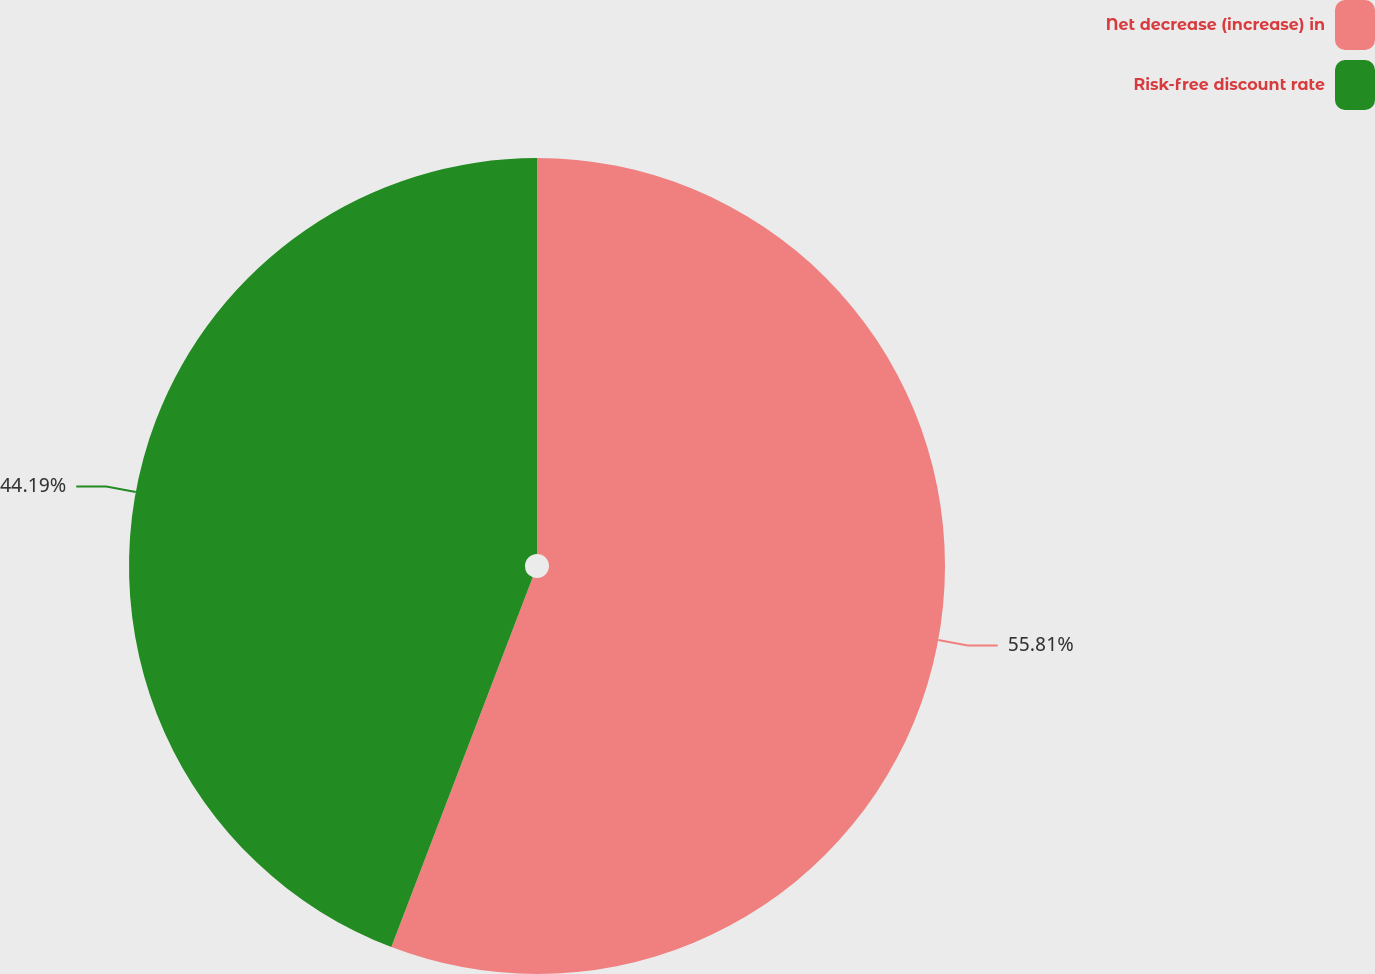Convert chart to OTSL. <chart><loc_0><loc_0><loc_500><loc_500><pie_chart><fcel>Net decrease (increase) in<fcel>Risk-free discount rate<nl><fcel>55.81%<fcel>44.19%<nl></chart> 